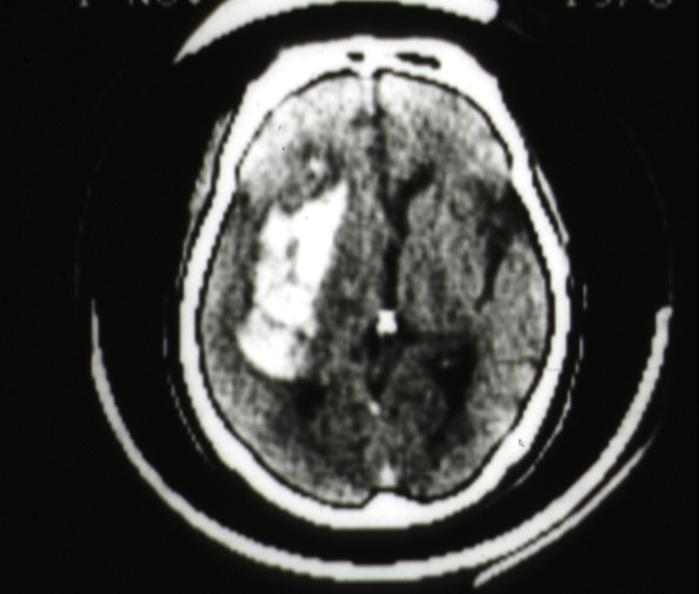what does cat scan?
Answer the question using a single word or phrase. Hemorrhage in putamen area 